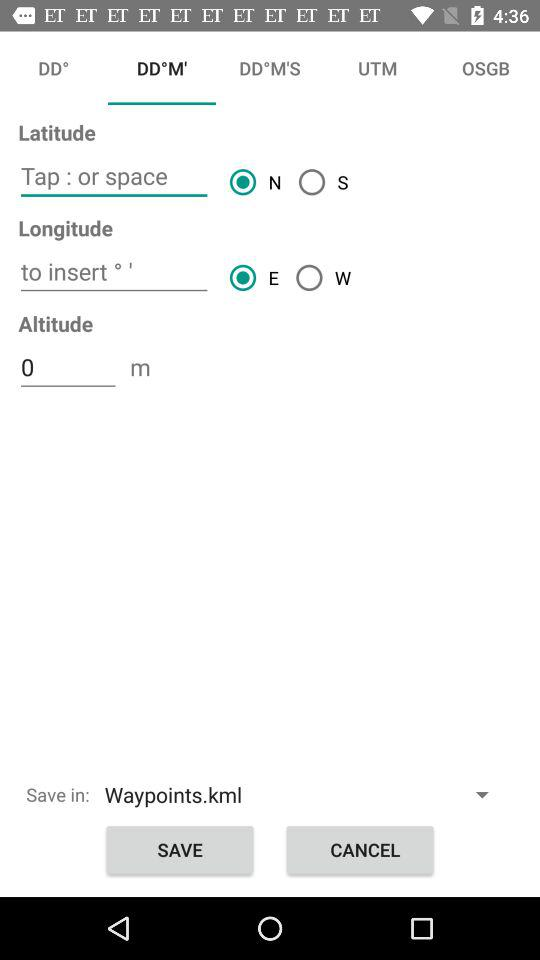Which direction is selected for latitude? The selected direction for latitude is north. 